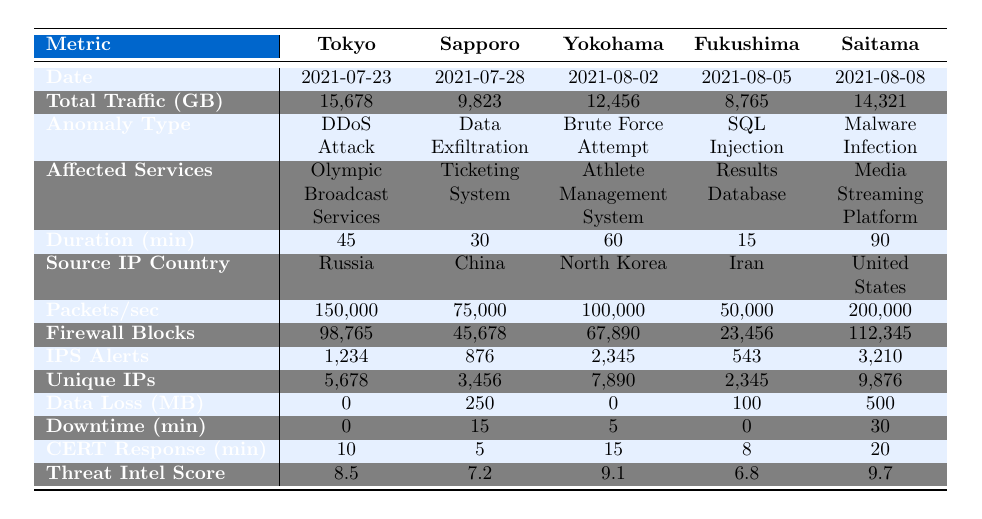What was the total traffic volume in Tokyo on July 23, 2021? The table lists the total traffic volume for Tokyo as 15,678 GB on the corresponding date.
Answer: 15,678 GB Which anomaly type affected the ticketing system? The table indicates that the ticketing system was affected by Data Exfiltration.
Answer: Data Exfiltration What was the duration of the DDoS attack? Looking at the table, the duration of the DDoS attack in Tokyo was 45 minutes.
Answer: 45 minutes How many unique IP addresses were involved in the malware infection? The table shows that the malware infection involved 9,876 unique IP addresses in Saitama.
Answer: 9,876 What is the total data loss during the Olympic events across all cities? Summing the data loss values: 0 + 250 + 0 + 100 + 500 gives a total data loss of 850 MB during the events.
Answer: 850 MB Which city had the highest number of firewall blocks? The table reveals that Saitama had the highest number of firewall blocks with 112,345.
Answer: Saitama Was there any system downtime during the SQL injection in Fukushima? Referring to the table, there was no system downtime reported during the SQL injection in Fukushima.
Answer: No Which city had the highest threat intelligence score and what was that score? By comparing the threat intelligence scores, Saitama had the highest score at 9.7.
Answer: 9.7 What is the average response time from CERT across all cities? The average CERT response time is calculated as (10 + 5 + 15 + 8 + 20) / 5 = 11.6 minutes.
Answer: 11.6 minutes Which city had the least duration of anomaly and what was the duration? Looking at the table, Fukushima had the least duration of 15 minutes for the SQL injection anomaly.
Answer: 15 minutes 